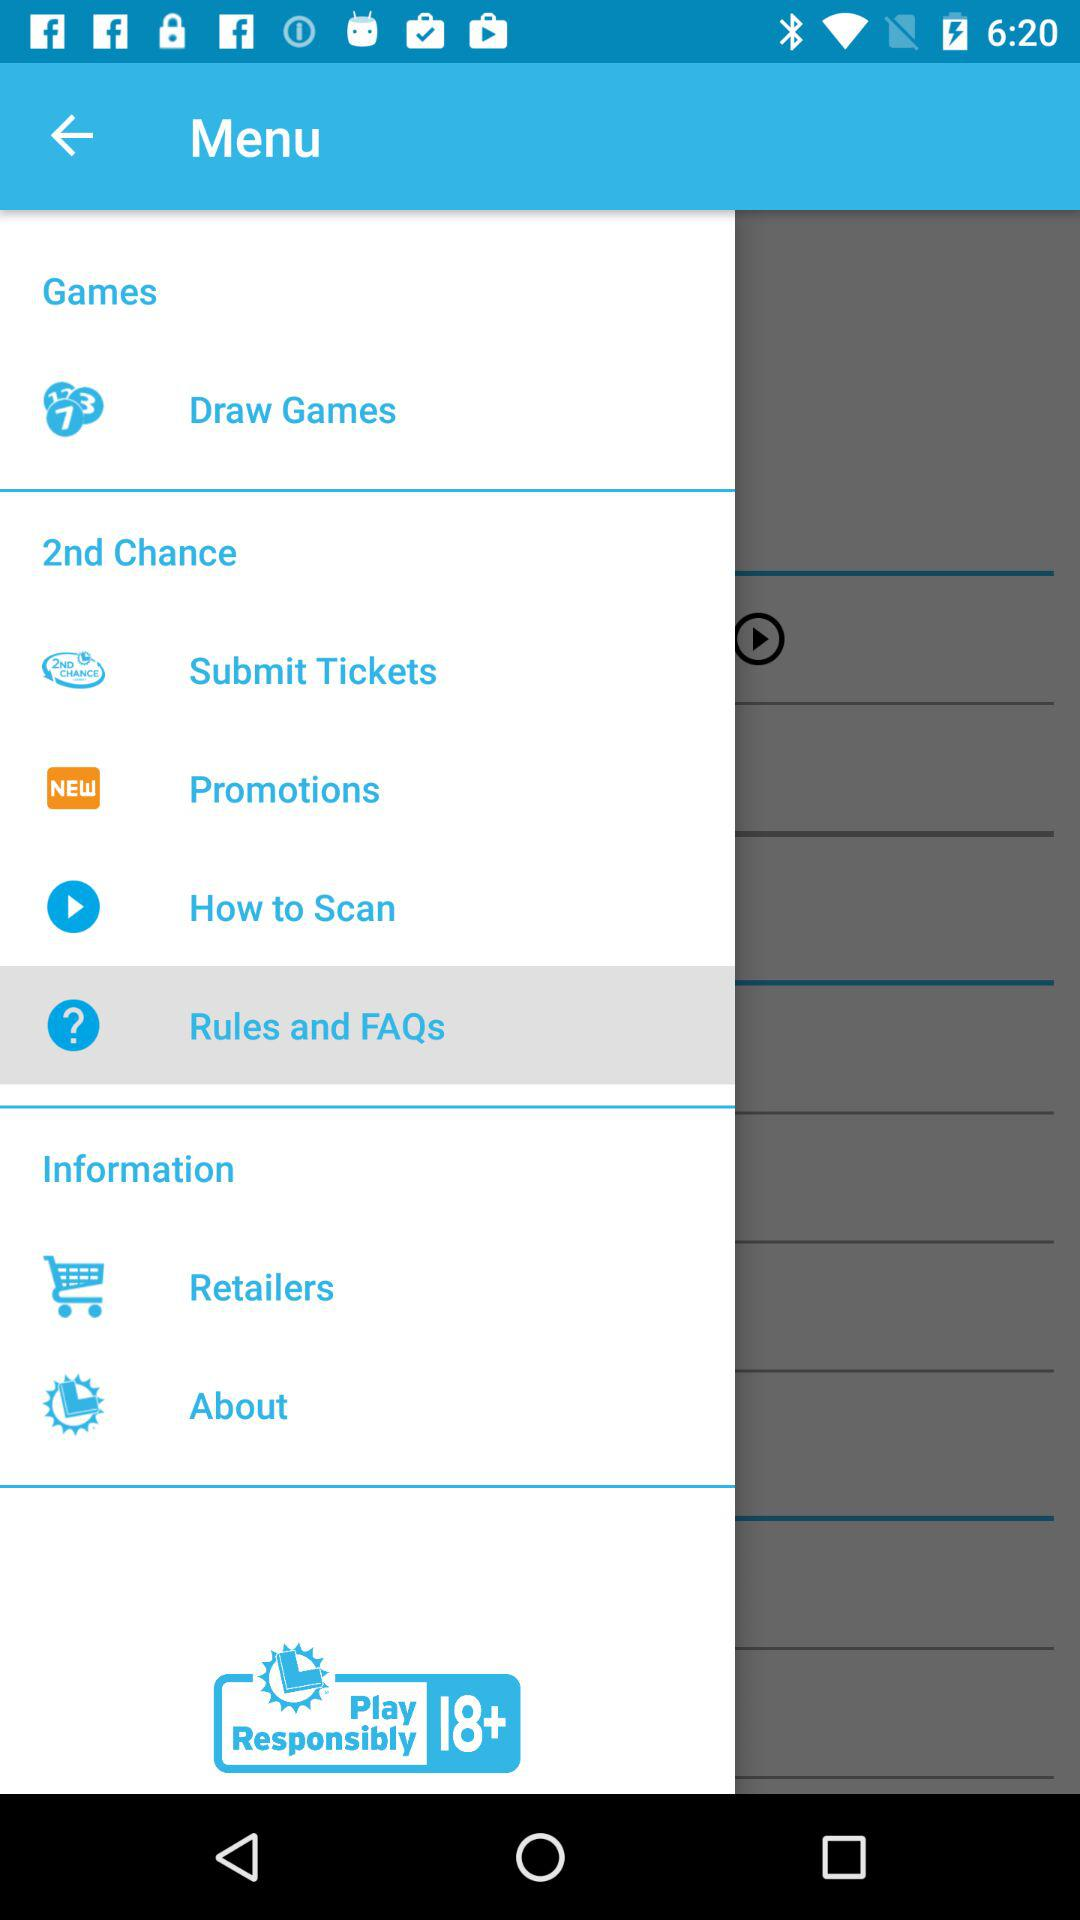Which item is selected? The selected items are "Rules and FAQs". 